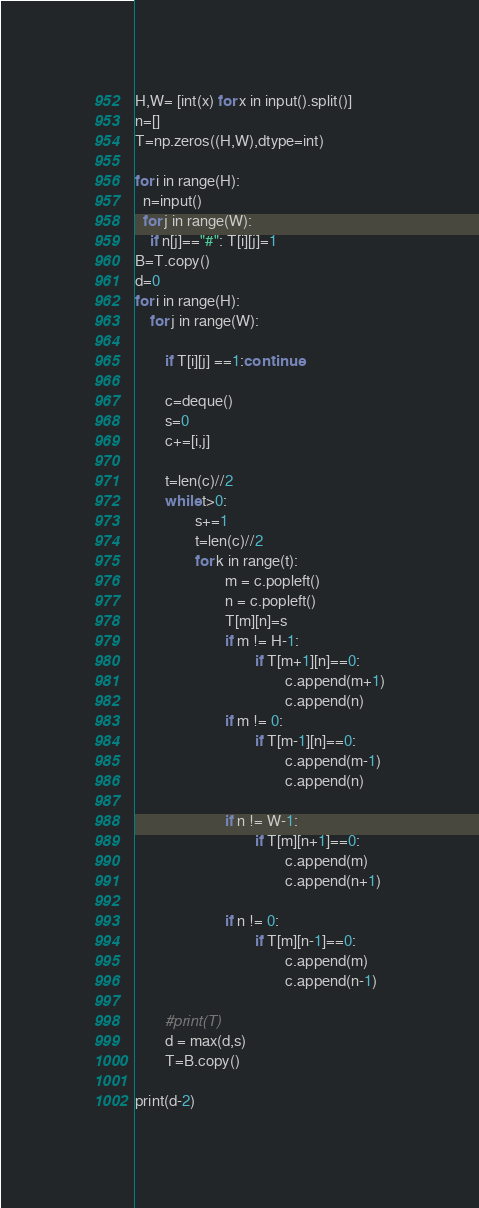<code> <loc_0><loc_0><loc_500><loc_500><_Python_>H,W= [int(x) for x in input().split()]
n=[]
T=np.zeros((H,W),dtype=int)

for i in range(H):
  n=input()
  for j in range(W):
    if n[j]=="#": T[i][j]=1
B=T.copy()    
d=0
for i in range(H):
    for j in range(W):
         
        if T[i][j] ==1:continue

        c=deque()    
        s=0
        c+=[i,j]
        
        t=len(c)//2
        while t>0:
                s+=1
                t=len(c)//2
                for k in range(t):
                        m = c.popleft()
                        n = c.popleft()
                        T[m][n]=s
                        if m != H-1:
                                if T[m+1][n]==0:
                                        c.append(m+1)
                                        c.append(n)
                        if m != 0:
                                if T[m-1][n]==0:
                                        c.append(m-1)
                                        c.append(n)
 
                        if n != W-1:
                                if T[m][n+1]==0:
                                        c.append(m)
                                        c.append(n+1)
                                        
                        if n != 0:
                                if T[m][n-1]==0:
                                        c.append(m)
                                        c.append(n-1)

        #print(T)
        d = max(d,s)
        T=B.copy()
        
print(d-2)</code> 